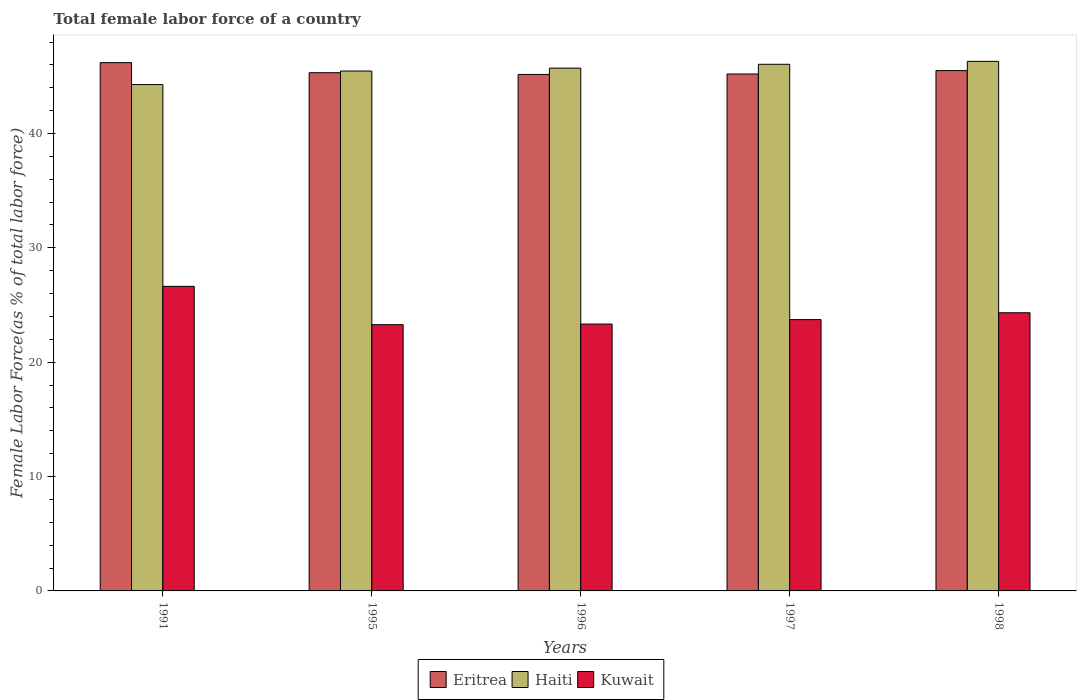How many different coloured bars are there?
Ensure brevity in your answer.  3. Are the number of bars on each tick of the X-axis equal?
Provide a succinct answer. Yes. How many bars are there on the 1st tick from the left?
Your response must be concise. 3. How many bars are there on the 1st tick from the right?
Ensure brevity in your answer.  3. What is the label of the 1st group of bars from the left?
Make the answer very short. 1991. In how many cases, is the number of bars for a given year not equal to the number of legend labels?
Make the answer very short. 0. What is the percentage of female labor force in Kuwait in 1991?
Give a very brief answer. 26.63. Across all years, what is the maximum percentage of female labor force in Haiti?
Offer a very short reply. 46.31. Across all years, what is the minimum percentage of female labor force in Haiti?
Provide a succinct answer. 44.28. What is the total percentage of female labor force in Kuwait in the graph?
Provide a succinct answer. 121.3. What is the difference between the percentage of female labor force in Haiti in 1995 and that in 1997?
Give a very brief answer. -0.59. What is the difference between the percentage of female labor force in Haiti in 1997 and the percentage of female labor force in Kuwait in 1995?
Ensure brevity in your answer.  22.77. What is the average percentage of female labor force in Eritrea per year?
Keep it short and to the point. 45.48. In the year 1991, what is the difference between the percentage of female labor force in Haiti and percentage of female labor force in Eritrea?
Offer a very short reply. -1.91. In how many years, is the percentage of female labor force in Kuwait greater than 2 %?
Your answer should be compact. 5. What is the ratio of the percentage of female labor force in Haiti in 1991 to that in 1995?
Your answer should be compact. 0.97. Is the difference between the percentage of female labor force in Haiti in 1997 and 1998 greater than the difference between the percentage of female labor force in Eritrea in 1997 and 1998?
Offer a terse response. Yes. What is the difference between the highest and the second highest percentage of female labor force in Haiti?
Offer a terse response. 0.26. What is the difference between the highest and the lowest percentage of female labor force in Eritrea?
Keep it short and to the point. 1.03. In how many years, is the percentage of female labor force in Eritrea greater than the average percentage of female labor force in Eritrea taken over all years?
Your answer should be compact. 2. Is the sum of the percentage of female labor force in Kuwait in 1995 and 1998 greater than the maximum percentage of female labor force in Eritrea across all years?
Your answer should be very brief. Yes. What does the 2nd bar from the left in 1996 represents?
Give a very brief answer. Haiti. What does the 3rd bar from the right in 1995 represents?
Provide a succinct answer. Eritrea. Is it the case that in every year, the sum of the percentage of female labor force in Eritrea and percentage of female labor force in Haiti is greater than the percentage of female labor force in Kuwait?
Your answer should be compact. Yes. What is the difference between two consecutive major ticks on the Y-axis?
Your response must be concise. 10. How many legend labels are there?
Provide a short and direct response. 3. What is the title of the graph?
Make the answer very short. Total female labor force of a country. Does "High income" appear as one of the legend labels in the graph?
Offer a terse response. No. What is the label or title of the Y-axis?
Your answer should be very brief. Female Labor Force(as % of total labor force). What is the Female Labor Force(as % of total labor force) in Eritrea in 1991?
Provide a short and direct response. 46.19. What is the Female Labor Force(as % of total labor force) of Haiti in 1991?
Provide a succinct answer. 44.28. What is the Female Labor Force(as % of total labor force) in Kuwait in 1991?
Your response must be concise. 26.63. What is the Female Labor Force(as % of total labor force) of Eritrea in 1995?
Offer a very short reply. 45.32. What is the Female Labor Force(as % of total labor force) of Haiti in 1995?
Give a very brief answer. 45.46. What is the Female Labor Force(as % of total labor force) in Kuwait in 1995?
Provide a short and direct response. 23.28. What is the Female Labor Force(as % of total labor force) in Eritrea in 1996?
Ensure brevity in your answer.  45.17. What is the Female Labor Force(as % of total labor force) in Haiti in 1996?
Offer a terse response. 45.72. What is the Female Labor Force(as % of total labor force) in Kuwait in 1996?
Provide a succinct answer. 23.34. What is the Female Labor Force(as % of total labor force) of Eritrea in 1997?
Offer a terse response. 45.2. What is the Female Labor Force(as % of total labor force) in Haiti in 1997?
Provide a succinct answer. 46.05. What is the Female Labor Force(as % of total labor force) of Kuwait in 1997?
Your response must be concise. 23.73. What is the Female Labor Force(as % of total labor force) of Eritrea in 1998?
Provide a short and direct response. 45.5. What is the Female Labor Force(as % of total labor force) of Haiti in 1998?
Provide a succinct answer. 46.31. What is the Female Labor Force(as % of total labor force) of Kuwait in 1998?
Give a very brief answer. 24.32. Across all years, what is the maximum Female Labor Force(as % of total labor force) of Eritrea?
Make the answer very short. 46.19. Across all years, what is the maximum Female Labor Force(as % of total labor force) of Haiti?
Make the answer very short. 46.31. Across all years, what is the maximum Female Labor Force(as % of total labor force) of Kuwait?
Provide a succinct answer. 26.63. Across all years, what is the minimum Female Labor Force(as % of total labor force) of Eritrea?
Your response must be concise. 45.17. Across all years, what is the minimum Female Labor Force(as % of total labor force) of Haiti?
Provide a succinct answer. 44.28. Across all years, what is the minimum Female Labor Force(as % of total labor force) of Kuwait?
Make the answer very short. 23.28. What is the total Female Labor Force(as % of total labor force) in Eritrea in the graph?
Offer a very short reply. 227.38. What is the total Female Labor Force(as % of total labor force) of Haiti in the graph?
Your answer should be very brief. 227.82. What is the total Female Labor Force(as % of total labor force) of Kuwait in the graph?
Give a very brief answer. 121.3. What is the difference between the Female Labor Force(as % of total labor force) of Eritrea in 1991 and that in 1995?
Give a very brief answer. 0.88. What is the difference between the Female Labor Force(as % of total labor force) of Haiti in 1991 and that in 1995?
Provide a succinct answer. -1.18. What is the difference between the Female Labor Force(as % of total labor force) of Kuwait in 1991 and that in 1995?
Keep it short and to the point. 3.35. What is the difference between the Female Labor Force(as % of total labor force) of Eritrea in 1991 and that in 1996?
Your answer should be compact. 1.03. What is the difference between the Female Labor Force(as % of total labor force) in Haiti in 1991 and that in 1996?
Ensure brevity in your answer.  -1.44. What is the difference between the Female Labor Force(as % of total labor force) in Kuwait in 1991 and that in 1996?
Your answer should be compact. 3.3. What is the difference between the Female Labor Force(as % of total labor force) in Haiti in 1991 and that in 1997?
Make the answer very short. -1.77. What is the difference between the Female Labor Force(as % of total labor force) of Kuwait in 1991 and that in 1997?
Offer a terse response. 2.91. What is the difference between the Female Labor Force(as % of total labor force) in Eritrea in 1991 and that in 1998?
Your answer should be compact. 0.69. What is the difference between the Female Labor Force(as % of total labor force) of Haiti in 1991 and that in 1998?
Keep it short and to the point. -2.03. What is the difference between the Female Labor Force(as % of total labor force) in Kuwait in 1991 and that in 1998?
Your answer should be very brief. 2.31. What is the difference between the Female Labor Force(as % of total labor force) in Eritrea in 1995 and that in 1996?
Your answer should be compact. 0.15. What is the difference between the Female Labor Force(as % of total labor force) of Haiti in 1995 and that in 1996?
Your response must be concise. -0.25. What is the difference between the Female Labor Force(as % of total labor force) of Kuwait in 1995 and that in 1996?
Provide a succinct answer. -0.05. What is the difference between the Female Labor Force(as % of total labor force) in Eritrea in 1995 and that in 1997?
Provide a short and direct response. 0.11. What is the difference between the Female Labor Force(as % of total labor force) in Haiti in 1995 and that in 1997?
Your answer should be compact. -0.59. What is the difference between the Female Labor Force(as % of total labor force) of Kuwait in 1995 and that in 1997?
Offer a very short reply. -0.44. What is the difference between the Female Labor Force(as % of total labor force) in Eritrea in 1995 and that in 1998?
Keep it short and to the point. -0.18. What is the difference between the Female Labor Force(as % of total labor force) of Haiti in 1995 and that in 1998?
Keep it short and to the point. -0.85. What is the difference between the Female Labor Force(as % of total labor force) of Kuwait in 1995 and that in 1998?
Provide a succinct answer. -1.04. What is the difference between the Female Labor Force(as % of total labor force) in Eritrea in 1996 and that in 1997?
Provide a short and direct response. -0.04. What is the difference between the Female Labor Force(as % of total labor force) of Haiti in 1996 and that in 1997?
Your answer should be very brief. -0.34. What is the difference between the Female Labor Force(as % of total labor force) of Kuwait in 1996 and that in 1997?
Provide a succinct answer. -0.39. What is the difference between the Female Labor Force(as % of total labor force) of Eritrea in 1996 and that in 1998?
Your response must be concise. -0.34. What is the difference between the Female Labor Force(as % of total labor force) in Haiti in 1996 and that in 1998?
Your answer should be compact. -0.59. What is the difference between the Female Labor Force(as % of total labor force) in Kuwait in 1996 and that in 1998?
Give a very brief answer. -0.99. What is the difference between the Female Labor Force(as % of total labor force) in Eritrea in 1997 and that in 1998?
Offer a very short reply. -0.3. What is the difference between the Female Labor Force(as % of total labor force) of Haiti in 1997 and that in 1998?
Your answer should be compact. -0.26. What is the difference between the Female Labor Force(as % of total labor force) in Kuwait in 1997 and that in 1998?
Provide a short and direct response. -0.6. What is the difference between the Female Labor Force(as % of total labor force) of Eritrea in 1991 and the Female Labor Force(as % of total labor force) of Haiti in 1995?
Give a very brief answer. 0.73. What is the difference between the Female Labor Force(as % of total labor force) of Eritrea in 1991 and the Female Labor Force(as % of total labor force) of Kuwait in 1995?
Provide a short and direct response. 22.91. What is the difference between the Female Labor Force(as % of total labor force) of Haiti in 1991 and the Female Labor Force(as % of total labor force) of Kuwait in 1995?
Give a very brief answer. 21. What is the difference between the Female Labor Force(as % of total labor force) of Eritrea in 1991 and the Female Labor Force(as % of total labor force) of Haiti in 1996?
Your response must be concise. 0.48. What is the difference between the Female Labor Force(as % of total labor force) of Eritrea in 1991 and the Female Labor Force(as % of total labor force) of Kuwait in 1996?
Make the answer very short. 22.86. What is the difference between the Female Labor Force(as % of total labor force) of Haiti in 1991 and the Female Labor Force(as % of total labor force) of Kuwait in 1996?
Make the answer very short. 20.94. What is the difference between the Female Labor Force(as % of total labor force) in Eritrea in 1991 and the Female Labor Force(as % of total labor force) in Haiti in 1997?
Keep it short and to the point. 0.14. What is the difference between the Female Labor Force(as % of total labor force) in Eritrea in 1991 and the Female Labor Force(as % of total labor force) in Kuwait in 1997?
Your answer should be compact. 22.47. What is the difference between the Female Labor Force(as % of total labor force) in Haiti in 1991 and the Female Labor Force(as % of total labor force) in Kuwait in 1997?
Ensure brevity in your answer.  20.55. What is the difference between the Female Labor Force(as % of total labor force) of Eritrea in 1991 and the Female Labor Force(as % of total labor force) of Haiti in 1998?
Your response must be concise. -0.11. What is the difference between the Female Labor Force(as % of total labor force) in Eritrea in 1991 and the Female Labor Force(as % of total labor force) in Kuwait in 1998?
Keep it short and to the point. 21.87. What is the difference between the Female Labor Force(as % of total labor force) in Haiti in 1991 and the Female Labor Force(as % of total labor force) in Kuwait in 1998?
Your answer should be compact. 19.96. What is the difference between the Female Labor Force(as % of total labor force) of Eritrea in 1995 and the Female Labor Force(as % of total labor force) of Haiti in 1996?
Offer a very short reply. -0.4. What is the difference between the Female Labor Force(as % of total labor force) in Eritrea in 1995 and the Female Labor Force(as % of total labor force) in Kuwait in 1996?
Your answer should be compact. 21.98. What is the difference between the Female Labor Force(as % of total labor force) in Haiti in 1995 and the Female Labor Force(as % of total labor force) in Kuwait in 1996?
Ensure brevity in your answer.  22.13. What is the difference between the Female Labor Force(as % of total labor force) in Eritrea in 1995 and the Female Labor Force(as % of total labor force) in Haiti in 1997?
Your answer should be compact. -0.74. What is the difference between the Female Labor Force(as % of total labor force) of Eritrea in 1995 and the Female Labor Force(as % of total labor force) of Kuwait in 1997?
Give a very brief answer. 21.59. What is the difference between the Female Labor Force(as % of total labor force) of Haiti in 1995 and the Female Labor Force(as % of total labor force) of Kuwait in 1997?
Provide a short and direct response. 21.74. What is the difference between the Female Labor Force(as % of total labor force) in Eritrea in 1995 and the Female Labor Force(as % of total labor force) in Haiti in 1998?
Offer a terse response. -0.99. What is the difference between the Female Labor Force(as % of total labor force) of Eritrea in 1995 and the Female Labor Force(as % of total labor force) of Kuwait in 1998?
Give a very brief answer. 20.99. What is the difference between the Female Labor Force(as % of total labor force) of Haiti in 1995 and the Female Labor Force(as % of total labor force) of Kuwait in 1998?
Your answer should be very brief. 21.14. What is the difference between the Female Labor Force(as % of total labor force) of Eritrea in 1996 and the Female Labor Force(as % of total labor force) of Haiti in 1997?
Offer a very short reply. -0.89. What is the difference between the Female Labor Force(as % of total labor force) in Eritrea in 1996 and the Female Labor Force(as % of total labor force) in Kuwait in 1997?
Keep it short and to the point. 21.44. What is the difference between the Female Labor Force(as % of total labor force) in Haiti in 1996 and the Female Labor Force(as % of total labor force) in Kuwait in 1997?
Give a very brief answer. 21.99. What is the difference between the Female Labor Force(as % of total labor force) in Eritrea in 1996 and the Female Labor Force(as % of total labor force) in Haiti in 1998?
Offer a very short reply. -1.14. What is the difference between the Female Labor Force(as % of total labor force) of Eritrea in 1996 and the Female Labor Force(as % of total labor force) of Kuwait in 1998?
Your response must be concise. 20.84. What is the difference between the Female Labor Force(as % of total labor force) in Haiti in 1996 and the Female Labor Force(as % of total labor force) in Kuwait in 1998?
Give a very brief answer. 21.39. What is the difference between the Female Labor Force(as % of total labor force) in Eritrea in 1997 and the Female Labor Force(as % of total labor force) in Haiti in 1998?
Give a very brief answer. -1.11. What is the difference between the Female Labor Force(as % of total labor force) of Eritrea in 1997 and the Female Labor Force(as % of total labor force) of Kuwait in 1998?
Offer a very short reply. 20.88. What is the difference between the Female Labor Force(as % of total labor force) of Haiti in 1997 and the Female Labor Force(as % of total labor force) of Kuwait in 1998?
Your answer should be compact. 21.73. What is the average Female Labor Force(as % of total labor force) in Eritrea per year?
Provide a succinct answer. 45.48. What is the average Female Labor Force(as % of total labor force) in Haiti per year?
Offer a very short reply. 45.56. What is the average Female Labor Force(as % of total labor force) of Kuwait per year?
Provide a short and direct response. 24.26. In the year 1991, what is the difference between the Female Labor Force(as % of total labor force) of Eritrea and Female Labor Force(as % of total labor force) of Haiti?
Provide a short and direct response. 1.91. In the year 1991, what is the difference between the Female Labor Force(as % of total labor force) in Eritrea and Female Labor Force(as % of total labor force) in Kuwait?
Give a very brief answer. 19.56. In the year 1991, what is the difference between the Female Labor Force(as % of total labor force) of Haiti and Female Labor Force(as % of total labor force) of Kuwait?
Your answer should be compact. 17.65. In the year 1995, what is the difference between the Female Labor Force(as % of total labor force) of Eritrea and Female Labor Force(as % of total labor force) of Haiti?
Make the answer very short. -0.15. In the year 1995, what is the difference between the Female Labor Force(as % of total labor force) of Eritrea and Female Labor Force(as % of total labor force) of Kuwait?
Keep it short and to the point. 22.03. In the year 1995, what is the difference between the Female Labor Force(as % of total labor force) of Haiti and Female Labor Force(as % of total labor force) of Kuwait?
Your answer should be compact. 22.18. In the year 1996, what is the difference between the Female Labor Force(as % of total labor force) of Eritrea and Female Labor Force(as % of total labor force) of Haiti?
Offer a terse response. -0.55. In the year 1996, what is the difference between the Female Labor Force(as % of total labor force) in Eritrea and Female Labor Force(as % of total labor force) in Kuwait?
Make the answer very short. 21.83. In the year 1996, what is the difference between the Female Labor Force(as % of total labor force) in Haiti and Female Labor Force(as % of total labor force) in Kuwait?
Provide a succinct answer. 22.38. In the year 1997, what is the difference between the Female Labor Force(as % of total labor force) of Eritrea and Female Labor Force(as % of total labor force) of Haiti?
Make the answer very short. -0.85. In the year 1997, what is the difference between the Female Labor Force(as % of total labor force) of Eritrea and Female Labor Force(as % of total labor force) of Kuwait?
Make the answer very short. 21.48. In the year 1997, what is the difference between the Female Labor Force(as % of total labor force) in Haiti and Female Labor Force(as % of total labor force) in Kuwait?
Your answer should be very brief. 22.33. In the year 1998, what is the difference between the Female Labor Force(as % of total labor force) of Eritrea and Female Labor Force(as % of total labor force) of Haiti?
Keep it short and to the point. -0.81. In the year 1998, what is the difference between the Female Labor Force(as % of total labor force) in Eritrea and Female Labor Force(as % of total labor force) in Kuwait?
Ensure brevity in your answer.  21.18. In the year 1998, what is the difference between the Female Labor Force(as % of total labor force) of Haiti and Female Labor Force(as % of total labor force) of Kuwait?
Provide a succinct answer. 21.98. What is the ratio of the Female Labor Force(as % of total labor force) in Eritrea in 1991 to that in 1995?
Your answer should be compact. 1.02. What is the ratio of the Female Labor Force(as % of total labor force) in Kuwait in 1991 to that in 1995?
Your answer should be very brief. 1.14. What is the ratio of the Female Labor Force(as % of total labor force) in Eritrea in 1991 to that in 1996?
Your response must be concise. 1.02. What is the ratio of the Female Labor Force(as % of total labor force) of Haiti in 1991 to that in 1996?
Provide a succinct answer. 0.97. What is the ratio of the Female Labor Force(as % of total labor force) of Kuwait in 1991 to that in 1996?
Provide a succinct answer. 1.14. What is the ratio of the Female Labor Force(as % of total labor force) of Eritrea in 1991 to that in 1997?
Ensure brevity in your answer.  1.02. What is the ratio of the Female Labor Force(as % of total labor force) of Haiti in 1991 to that in 1997?
Provide a short and direct response. 0.96. What is the ratio of the Female Labor Force(as % of total labor force) of Kuwait in 1991 to that in 1997?
Offer a terse response. 1.12. What is the ratio of the Female Labor Force(as % of total labor force) in Eritrea in 1991 to that in 1998?
Make the answer very short. 1.02. What is the ratio of the Female Labor Force(as % of total labor force) of Haiti in 1991 to that in 1998?
Ensure brevity in your answer.  0.96. What is the ratio of the Female Labor Force(as % of total labor force) of Kuwait in 1991 to that in 1998?
Provide a succinct answer. 1.09. What is the ratio of the Female Labor Force(as % of total labor force) in Haiti in 1995 to that in 1996?
Offer a terse response. 0.99. What is the ratio of the Female Labor Force(as % of total labor force) of Haiti in 1995 to that in 1997?
Provide a succinct answer. 0.99. What is the ratio of the Female Labor Force(as % of total labor force) of Kuwait in 1995 to that in 1997?
Ensure brevity in your answer.  0.98. What is the ratio of the Female Labor Force(as % of total labor force) of Haiti in 1995 to that in 1998?
Make the answer very short. 0.98. What is the ratio of the Female Labor Force(as % of total labor force) of Kuwait in 1995 to that in 1998?
Your answer should be very brief. 0.96. What is the ratio of the Female Labor Force(as % of total labor force) of Haiti in 1996 to that in 1997?
Offer a terse response. 0.99. What is the ratio of the Female Labor Force(as % of total labor force) in Kuwait in 1996 to that in 1997?
Provide a short and direct response. 0.98. What is the ratio of the Female Labor Force(as % of total labor force) in Haiti in 1996 to that in 1998?
Give a very brief answer. 0.99. What is the ratio of the Female Labor Force(as % of total labor force) of Kuwait in 1996 to that in 1998?
Offer a very short reply. 0.96. What is the ratio of the Female Labor Force(as % of total labor force) in Kuwait in 1997 to that in 1998?
Your answer should be compact. 0.98. What is the difference between the highest and the second highest Female Labor Force(as % of total labor force) in Eritrea?
Your response must be concise. 0.69. What is the difference between the highest and the second highest Female Labor Force(as % of total labor force) in Haiti?
Offer a very short reply. 0.26. What is the difference between the highest and the second highest Female Labor Force(as % of total labor force) in Kuwait?
Keep it short and to the point. 2.31. What is the difference between the highest and the lowest Female Labor Force(as % of total labor force) in Eritrea?
Provide a short and direct response. 1.03. What is the difference between the highest and the lowest Female Labor Force(as % of total labor force) in Haiti?
Your response must be concise. 2.03. What is the difference between the highest and the lowest Female Labor Force(as % of total labor force) of Kuwait?
Make the answer very short. 3.35. 